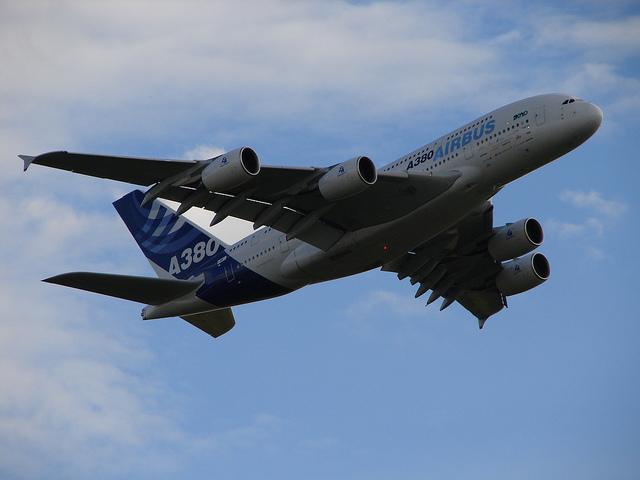How many engines does the plane have?
Keep it brief. 4. What is the jet's number?
Give a very brief answer. A380. Is the plain white?
Quick response, please. Yes. Are the wheels put away?
Keep it brief. Yes. Is this a big plane?
Be succinct. Yes. What letters are on the airplane?
Short answer required. Airbus. What color is the sky?
Quick response, please. Blue. What is the plane's call sign on the tail?
Quick response, please. A380. 